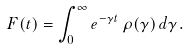<formula> <loc_0><loc_0><loc_500><loc_500>F ( t ) = \int _ { 0 } ^ { \infty } e ^ { - \gamma t } \, \rho ( \gamma ) \, d \gamma .</formula> 